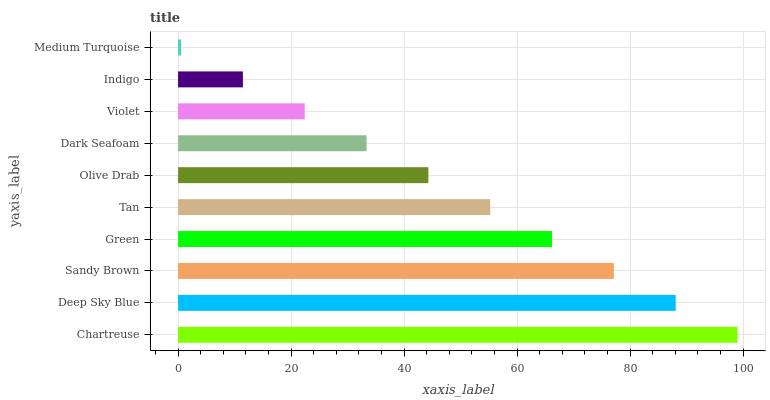Is Medium Turquoise the minimum?
Answer yes or no. Yes. Is Chartreuse the maximum?
Answer yes or no. Yes. Is Deep Sky Blue the minimum?
Answer yes or no. No. Is Deep Sky Blue the maximum?
Answer yes or no. No. Is Chartreuse greater than Deep Sky Blue?
Answer yes or no. Yes. Is Deep Sky Blue less than Chartreuse?
Answer yes or no. Yes. Is Deep Sky Blue greater than Chartreuse?
Answer yes or no. No. Is Chartreuse less than Deep Sky Blue?
Answer yes or no. No. Is Tan the high median?
Answer yes or no. Yes. Is Olive Drab the low median?
Answer yes or no. Yes. Is Olive Drab the high median?
Answer yes or no. No. Is Medium Turquoise the low median?
Answer yes or no. No. 